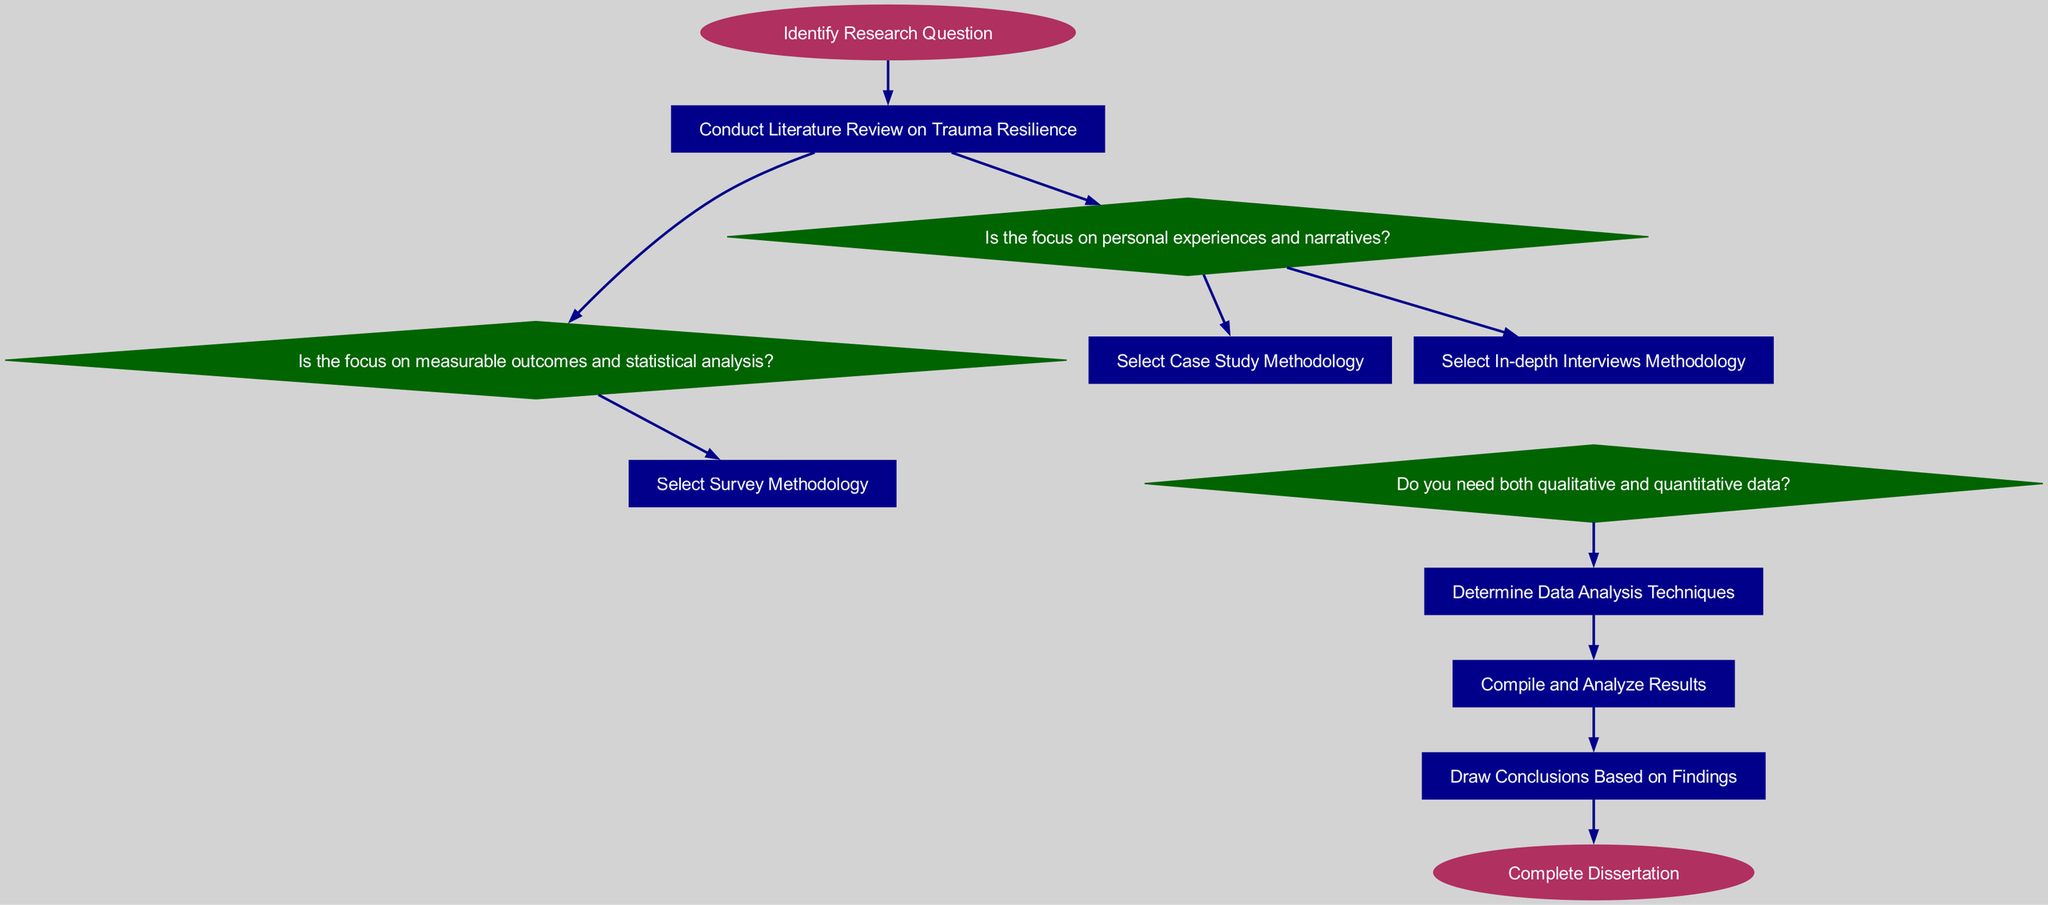What is the first step in the diagram? The first step is identified as "Identify Research Question" which is the starting point of the flowchart.
Answer: Identify Research Question How many main research methodologies are suggested after the literature review? After the literature review, the diagram suggests three main methodologies: qualitative, quantitative, and mixed methods.
Answer: Three Which node leads to 'Select In-depth Interviews Methodology'? The node 'Is the focus on personal experiences and narratives?' connects to 'Select In-depth Interviews Methodology' indicating a focus on qualitative research.
Answer: Is the focus on personal experiences and narratives? What do you determine after selecting a methodology? After selecting a methodology, the next logical step in the flow is to determine the appropriate data analysis techniques.
Answer: Determine Data Analysis Techniques What is the final outcome of the flowchart? The final outcome of the flowchart, represented by the last node, is "Complete Dissertation". This signifies the end of the decision-making process.
Answer: Complete Dissertation From 'Is the focus on measurable outcomes and statistical analysis?', which methodology is selected? The diagram directs from 'Is the focus on measurable outcomes and statistical analysis?' to 'Select Survey Methodology', indicating that quantitative analysis leads to surveys.
Answer: Select Survey Methodology What is the shape of the node that represents qualitative methods? The qualitative methods node is represented by a diamond shape, which is a characteristic distinction for decision points or methodologies within the flow chart.
Answer: Diamond If a researcher decides to use mixed methods, what is the next step in the flow? If the researcher decides to use mixed methods, the next step will be to determine the data analysis techniques, following the mixed methods node in the diagram.
Answer: Determine Data Analysis Techniques How many edges connect from the node 'Conduct Literature Review on Trauma Resilience'? There are three edges connecting from 'Conduct Literature Review on Trauma Resilience' to the next nodes: 'Is the focus on personal experiences and narratives?', 'Is the focus on measurable outcomes and statistical analysis?', and 'Do you need both qualitative and quantitative data?'.
Answer: Three 